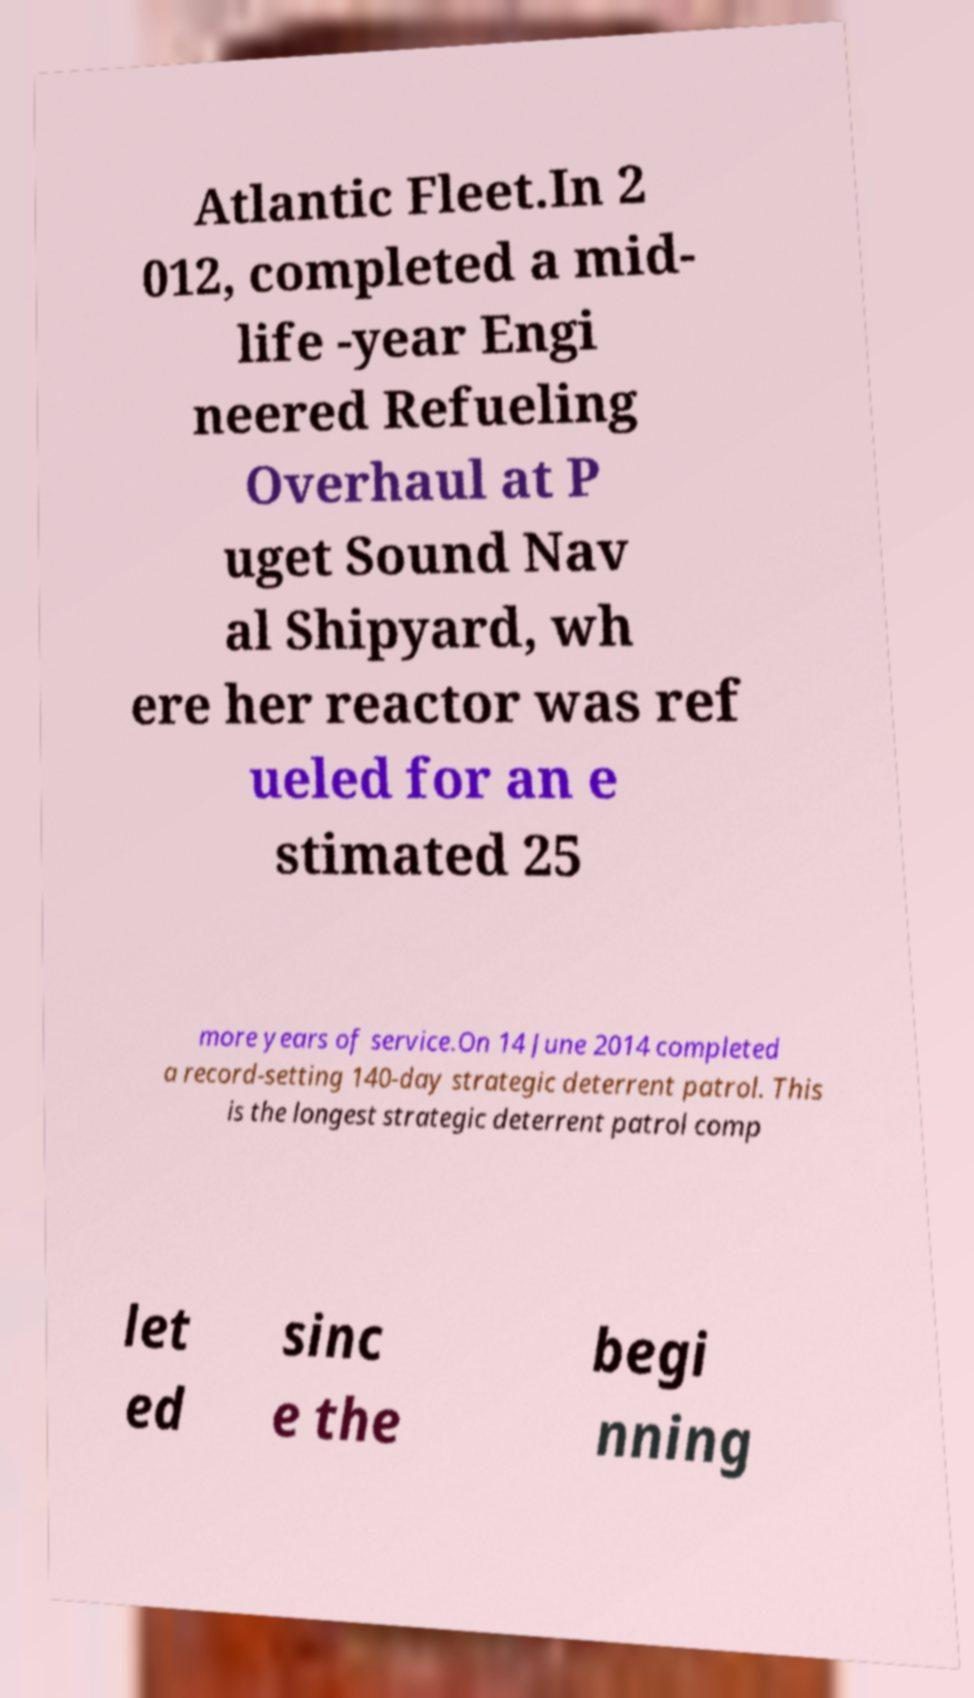Please read and relay the text visible in this image. What does it say? Atlantic Fleet.In 2 012, completed a mid- life -year Engi neered Refueling Overhaul at P uget Sound Nav al Shipyard, wh ere her reactor was ref ueled for an e stimated 25 more years of service.On 14 June 2014 completed a record-setting 140-day strategic deterrent patrol. This is the longest strategic deterrent patrol comp let ed sinc e the begi nning 